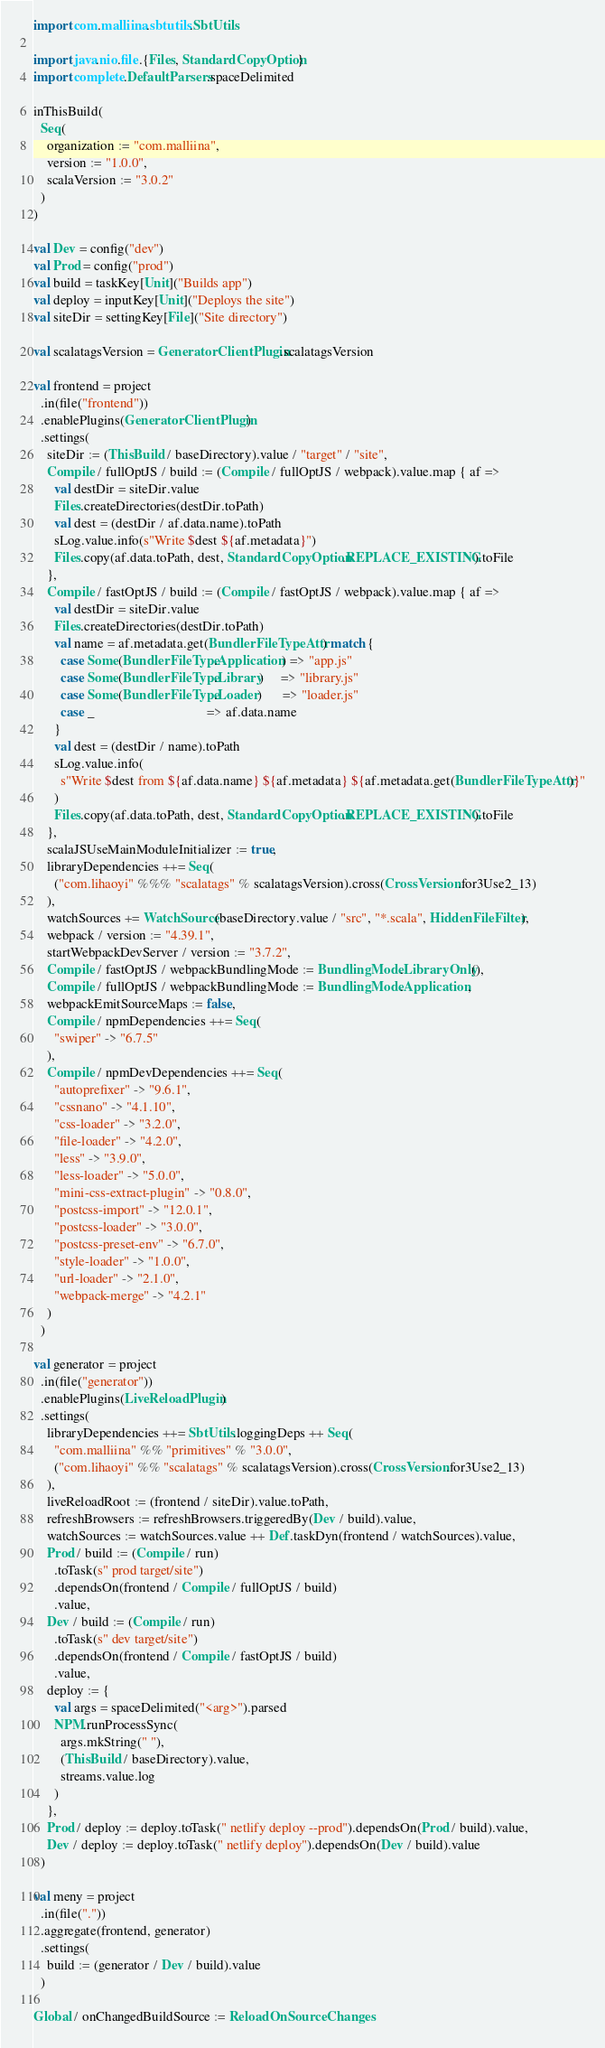<code> <loc_0><loc_0><loc_500><loc_500><_Scala_>import com.malliina.sbtutils.SbtUtils

import java.nio.file.{Files, StandardCopyOption}
import complete.DefaultParsers.spaceDelimited

inThisBuild(
  Seq(
    organization := "com.malliina",
    version := "1.0.0",
    scalaVersion := "3.0.2"
  )
)

val Dev = config("dev")
val Prod = config("prod")
val build = taskKey[Unit]("Builds app")
val deploy = inputKey[Unit]("Deploys the site")
val siteDir = settingKey[File]("Site directory")

val scalatagsVersion = GeneratorClientPlugin.scalatagsVersion

val frontend = project
  .in(file("frontend"))
  .enablePlugins(GeneratorClientPlugin)
  .settings(
    siteDir := (ThisBuild / baseDirectory).value / "target" / "site",
    Compile / fullOptJS / build := (Compile / fullOptJS / webpack).value.map { af =>
      val destDir = siteDir.value
      Files.createDirectories(destDir.toPath)
      val dest = (destDir / af.data.name).toPath
      sLog.value.info(s"Write $dest ${af.metadata}")
      Files.copy(af.data.toPath, dest, StandardCopyOption.REPLACE_EXISTING).toFile
    },
    Compile / fastOptJS / build := (Compile / fastOptJS / webpack).value.map { af =>
      val destDir = siteDir.value
      Files.createDirectories(destDir.toPath)
      val name = af.metadata.get(BundlerFileTypeAttr) match {
        case Some(BundlerFileType.Application) => "app.js"
        case Some(BundlerFileType.Library)     => "library.js"
        case Some(BundlerFileType.Loader)      => "loader.js"
        case _                                 => af.data.name
      }
      val dest = (destDir / name).toPath
      sLog.value.info(
        s"Write $dest from ${af.data.name} ${af.metadata} ${af.metadata.get(BundlerFileTypeAttr)}"
      )
      Files.copy(af.data.toPath, dest, StandardCopyOption.REPLACE_EXISTING).toFile
    },
    scalaJSUseMainModuleInitializer := true,
    libraryDependencies ++= Seq(
      ("com.lihaoyi" %%% "scalatags" % scalatagsVersion).cross(CrossVersion.for3Use2_13)
    ),
    watchSources += WatchSource(baseDirectory.value / "src", "*.scala", HiddenFileFilter),
    webpack / version := "4.39.1",
    startWebpackDevServer / version := "3.7.2",
    Compile / fastOptJS / webpackBundlingMode := BundlingMode.LibraryOnly(),
    Compile / fullOptJS / webpackBundlingMode := BundlingMode.Application,
    webpackEmitSourceMaps := false,
    Compile / npmDependencies ++= Seq(
      "swiper" -> "6.7.5"
    ),
    Compile / npmDevDependencies ++= Seq(
      "autoprefixer" -> "9.6.1",
      "cssnano" -> "4.1.10",
      "css-loader" -> "3.2.0",
      "file-loader" -> "4.2.0",
      "less" -> "3.9.0",
      "less-loader" -> "5.0.0",
      "mini-css-extract-plugin" -> "0.8.0",
      "postcss-import" -> "12.0.1",
      "postcss-loader" -> "3.0.0",
      "postcss-preset-env" -> "6.7.0",
      "style-loader" -> "1.0.0",
      "url-loader" -> "2.1.0",
      "webpack-merge" -> "4.2.1"
    )
  )

val generator = project
  .in(file("generator"))
  .enablePlugins(LiveReloadPlugin)
  .settings(
    libraryDependencies ++= SbtUtils.loggingDeps ++ Seq(
      "com.malliina" %% "primitives" % "3.0.0",
      ("com.lihaoyi" %% "scalatags" % scalatagsVersion).cross(CrossVersion.for3Use2_13)
    ),
    liveReloadRoot := (frontend / siteDir).value.toPath,
    refreshBrowsers := refreshBrowsers.triggeredBy(Dev / build).value,
    watchSources := watchSources.value ++ Def.taskDyn(frontend / watchSources).value,
    Prod / build := (Compile / run)
      .toTask(s" prod target/site")
      .dependsOn(frontend / Compile / fullOptJS / build)
      .value,
    Dev / build := (Compile / run)
      .toTask(s" dev target/site")
      .dependsOn(frontend / Compile / fastOptJS / build)
      .value,
    deploy := {
      val args = spaceDelimited("<arg>").parsed
      NPM.runProcessSync(
        args.mkString(" "),
        (ThisBuild / baseDirectory).value,
        streams.value.log
      )
    },
    Prod / deploy := deploy.toTask(" netlify deploy --prod").dependsOn(Prod / build).value,
    Dev / deploy := deploy.toTask(" netlify deploy").dependsOn(Dev / build).value
  )

val meny = project
  .in(file("."))
  .aggregate(frontend, generator)
  .settings(
    build := (generator / Dev / build).value
  )

Global / onChangedBuildSource := ReloadOnSourceChanges
</code> 